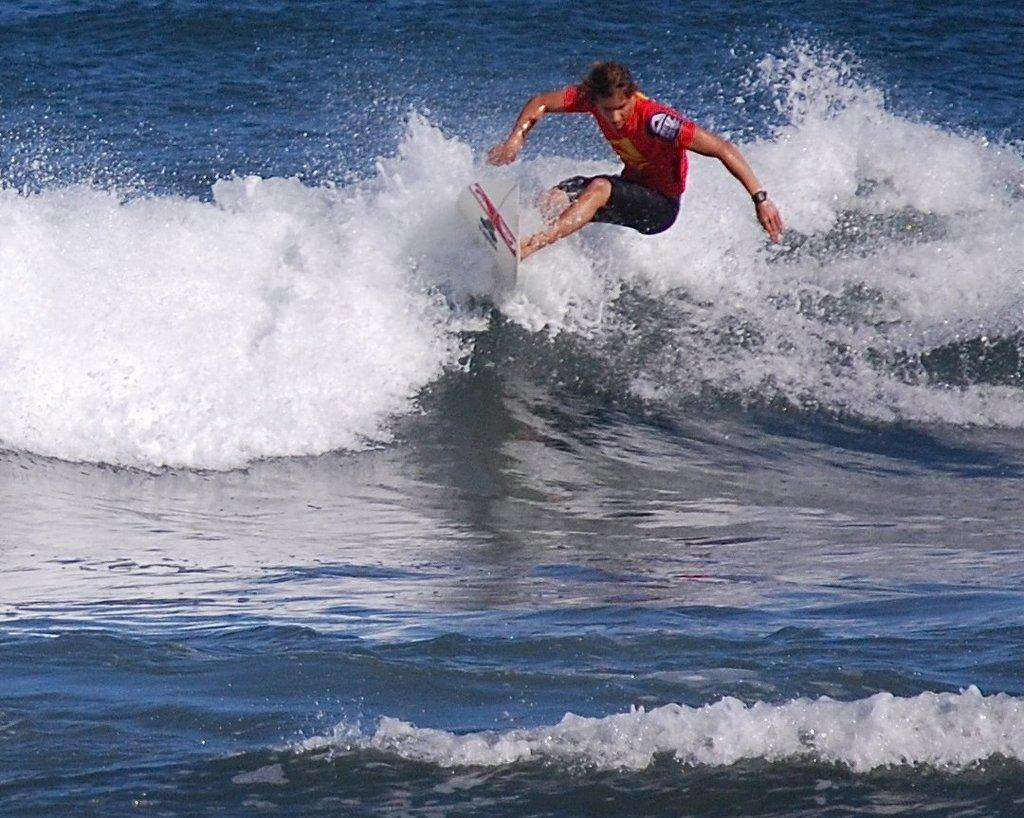What is the person in the image doing? The person is surfing in the sea. What is the person wearing while surfing? The person is wearing a red color t-shirt and black color shorts. What type of blade is being used by the person in the bedroom? There is no bedroom or blade present in the image; the person is surfing in the sea. 